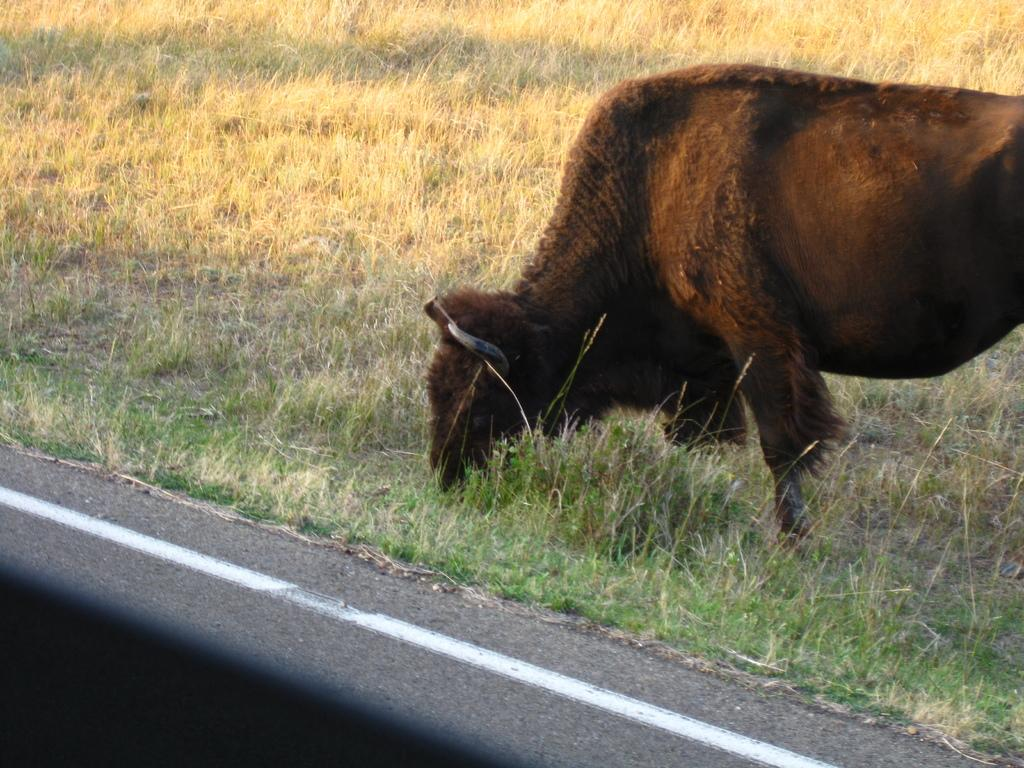What type of animal is present in the image? Unfortunately, the provided facts do not specify the type of animal in the image. What type of vegetation can be seen at the bottom of the image? There is grass visible at the bottom of the image. How does the animal fold its legs in the image? There is no information provided about the animal's legs or their position in the image. 